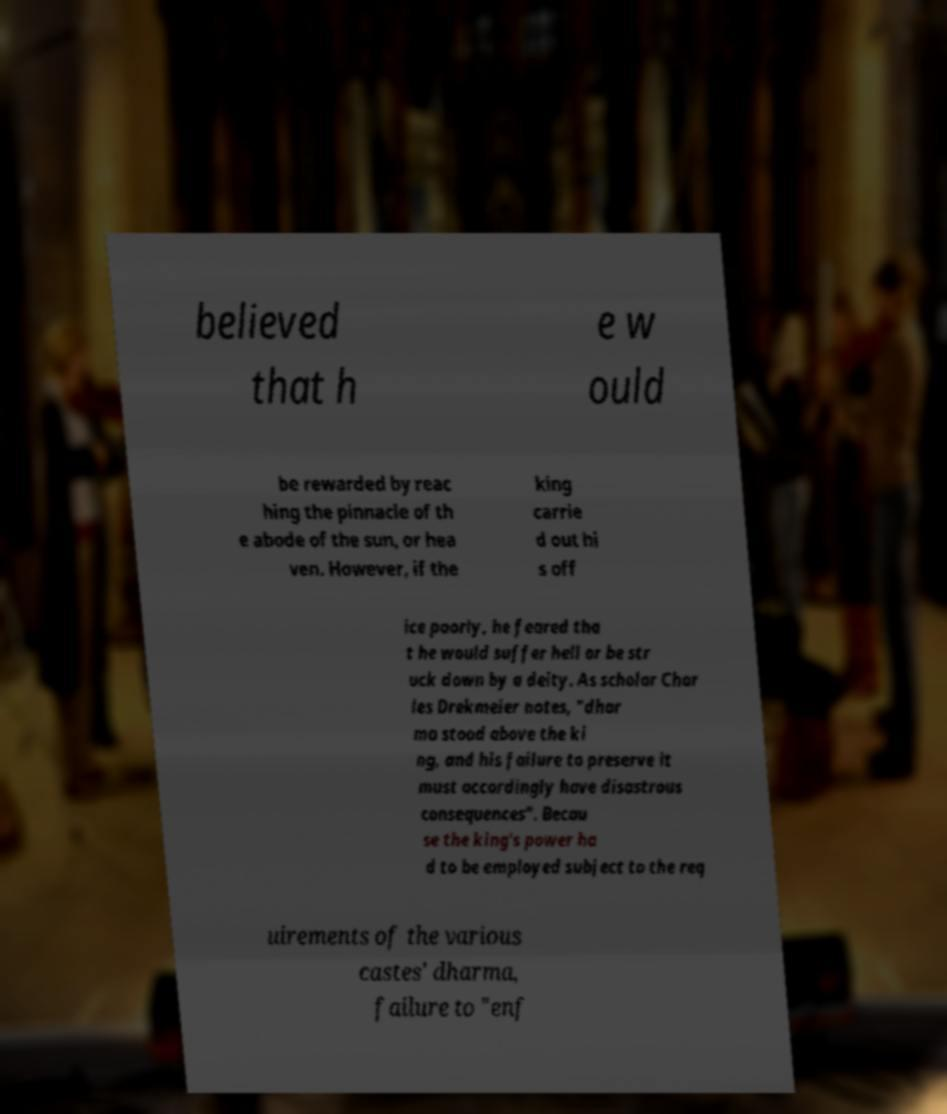What messages or text are displayed in this image? I need them in a readable, typed format. believed that h e w ould be rewarded by reac hing the pinnacle of th e abode of the sun, or hea ven. However, if the king carrie d out hi s off ice poorly, he feared tha t he would suffer hell or be str uck down by a deity. As scholar Char les Drekmeier notes, "dhar ma stood above the ki ng, and his failure to preserve it must accordingly have disastrous consequences". Becau se the king's power ha d to be employed subject to the req uirements of the various castes' dharma, failure to "enf 